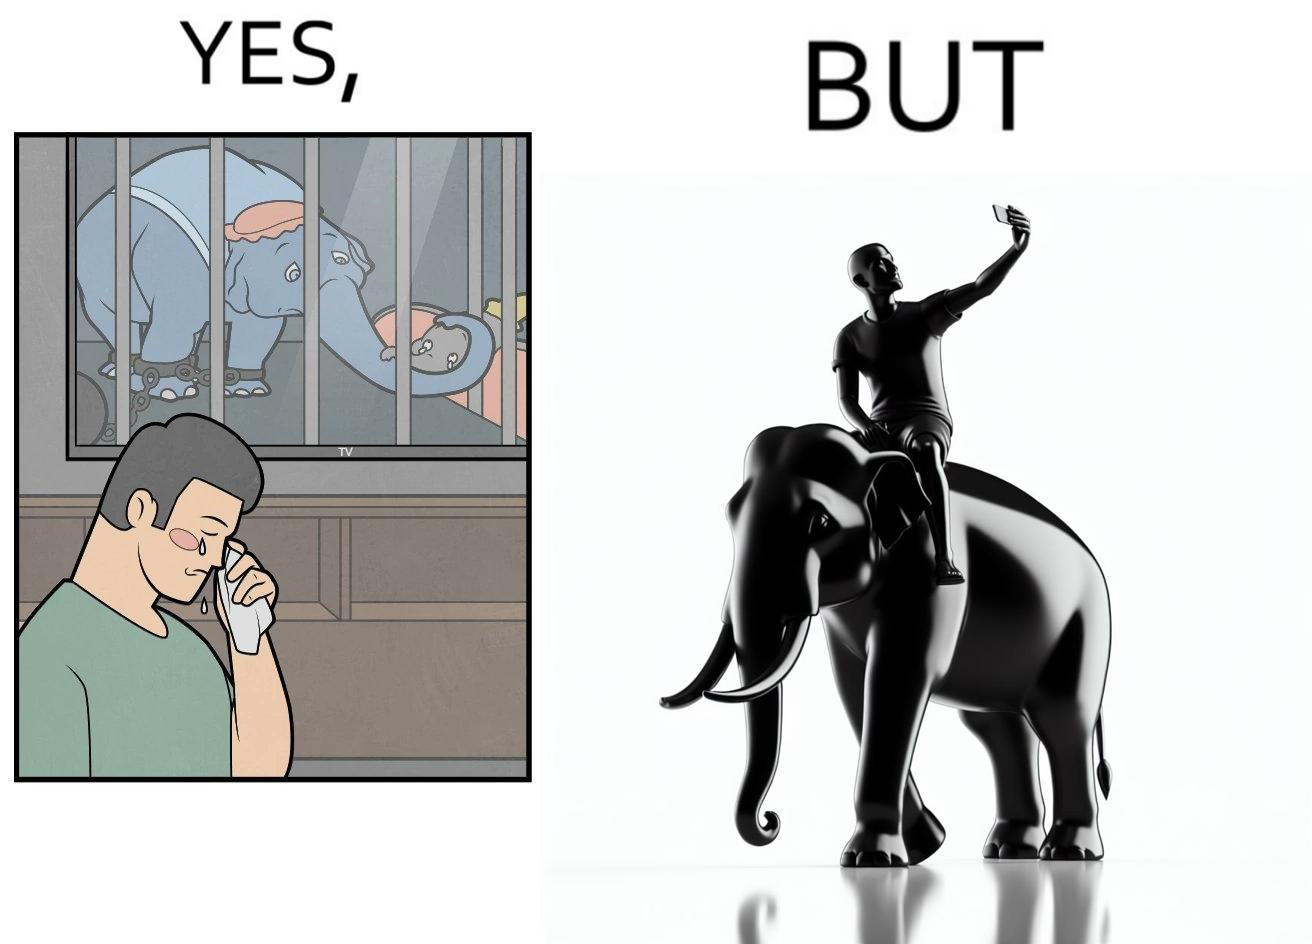Describe the contrast between the left and right parts of this image. In the left part of the image: a man crying on seeing an elephant being chained in a cage in a TV program In the right part of the image: a person riding an elephant while taking selfies 